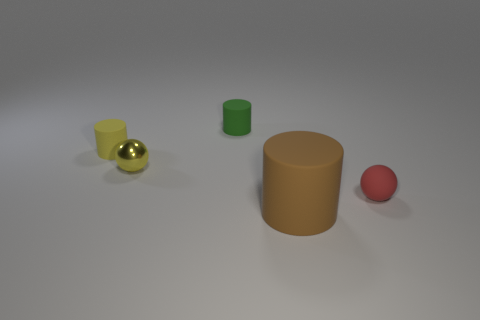There is a ball that is left of the tiny sphere right of the cylinder right of the green cylinder; what is its material?
Provide a short and direct response. Metal. Is there another object of the same size as the brown thing?
Provide a succinct answer. No. There is a small green object; what shape is it?
Provide a succinct answer. Cylinder. What number of cylinders are small yellow matte things or small metallic objects?
Offer a very short reply. 1. Are there an equal number of large brown cylinders behind the tiny red object and large rubber things that are right of the brown object?
Your answer should be compact. Yes. How many tiny balls are behind the sphere to the right of the sphere behind the small red matte sphere?
Offer a very short reply. 1. Do the large rubber cylinder and the tiny object that is right of the large brown cylinder have the same color?
Make the answer very short. No. Are there more green rubber cylinders in front of the red rubber sphere than cylinders?
Ensure brevity in your answer.  No. What number of things are either objects left of the red object or rubber cylinders behind the tiny red matte thing?
Offer a terse response. 4. What size is the brown cylinder that is the same material as the small red object?
Offer a very short reply. Large. 